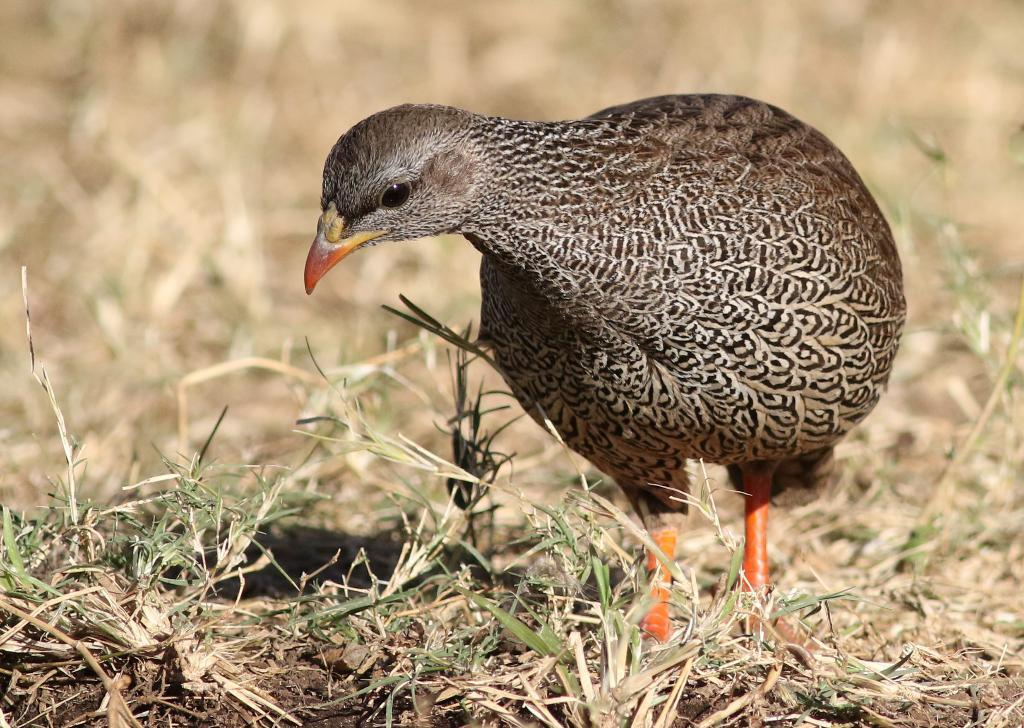What type of vegetation is present in the image? There is grass in the image. What kind of animal can be seen in the image? There is a brown color bird in the image. How would you describe the quality of the image's background? The image is slightly blurry in the background. What type of treatment is the bird receiving in the image? There is no indication in the image that the bird is receiving any treatment. How many snails can be seen in the image? There are no snails present in the image. 